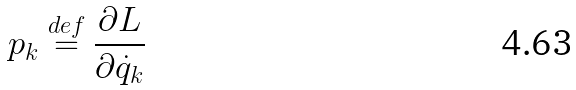Convert formula to latex. <formula><loc_0><loc_0><loc_500><loc_500>p _ { k } \ { \stackrel { d e f } { = } } \ { \frac { \partial L } { \partial { \dot { q } } _ { k } } }</formula> 